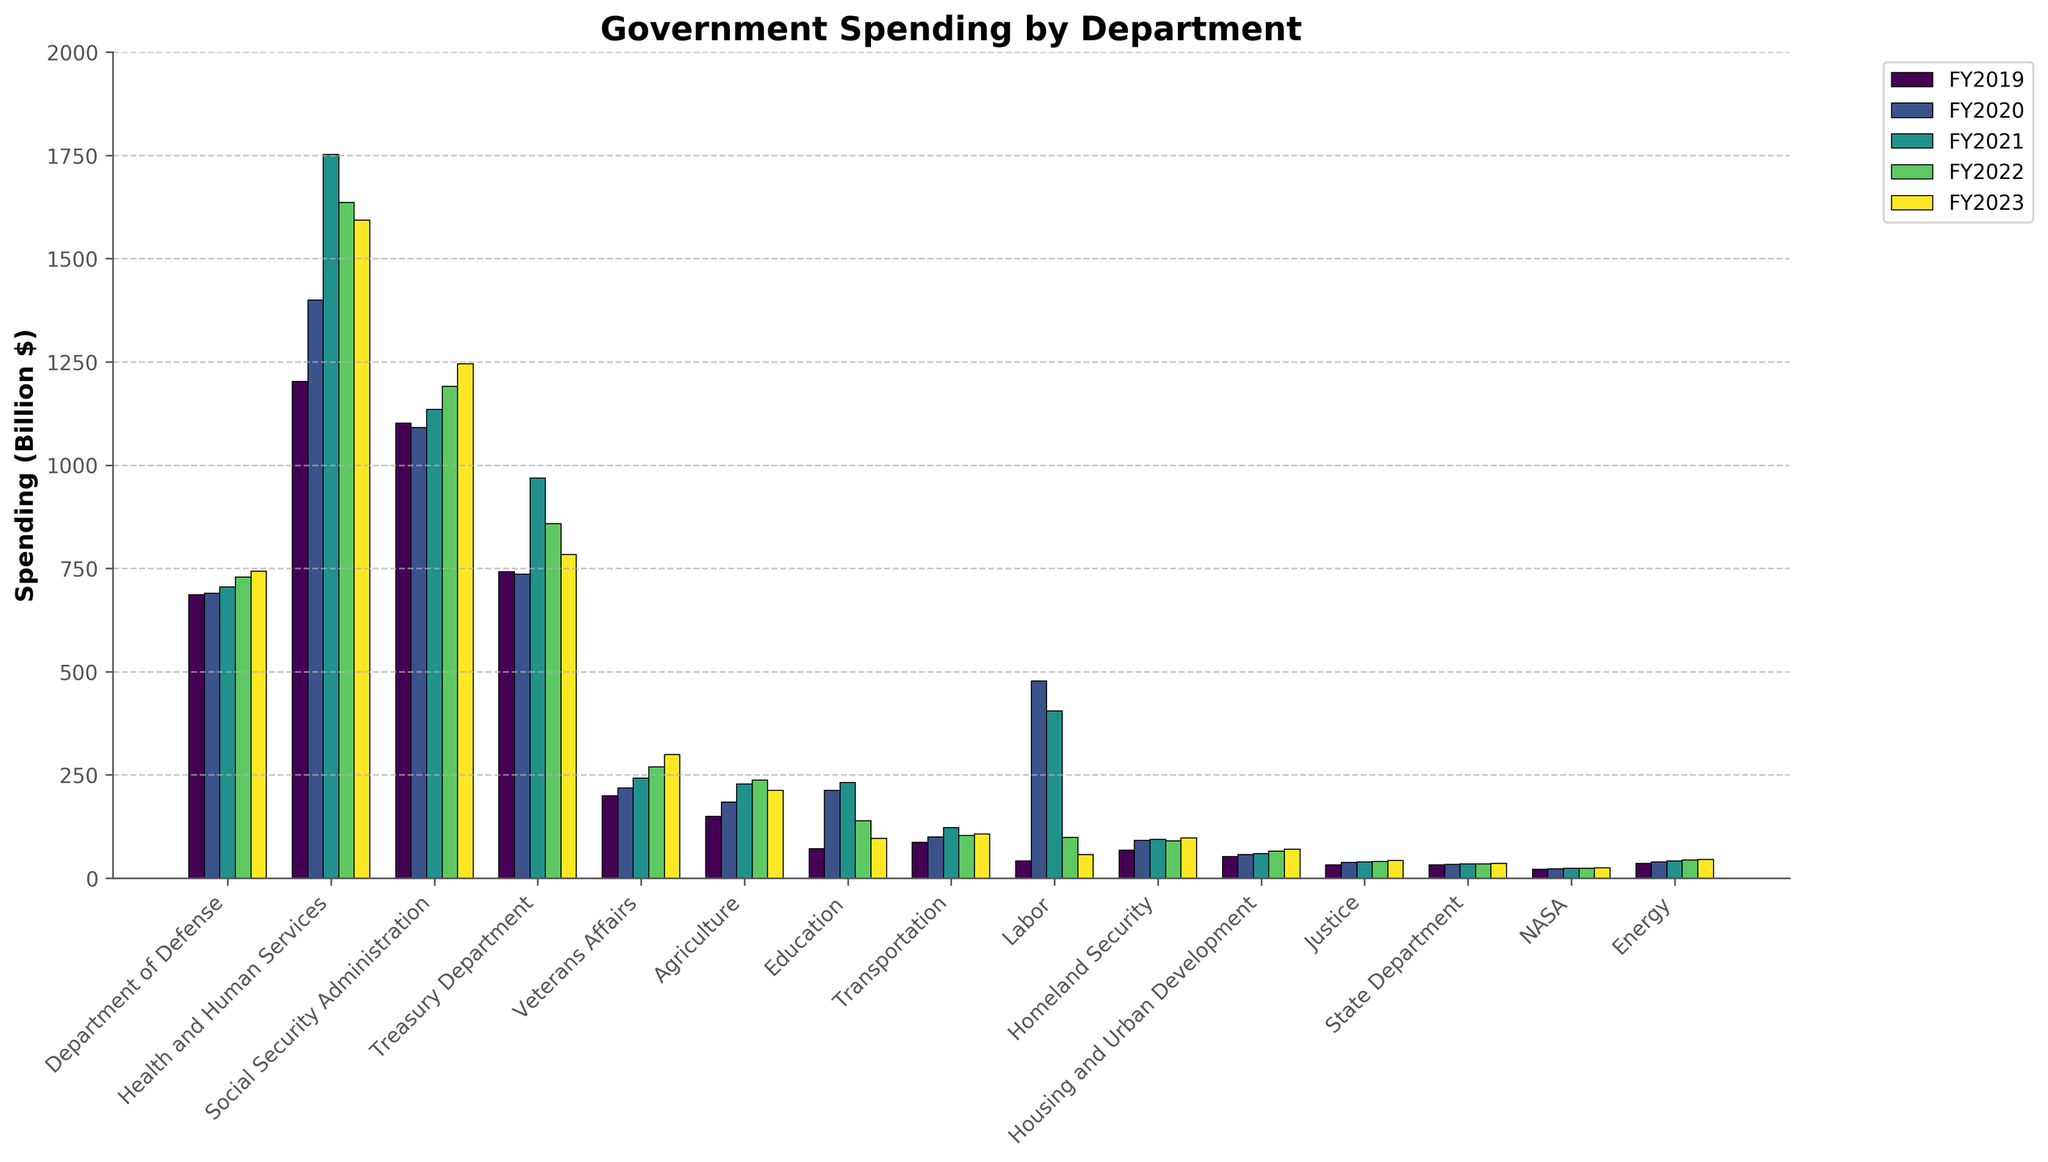What is the total amount of spending by the Department of Defense over the 5 fiscal years? Sum the values for the Department of Defense across FY2019 to FY2023: 686.1 + 690.0 + 705.4 + 728.5 + 743.2 = 3553.2
Answer: 3553.2 Which department had the highest spending in any single fiscal year displayed in the figure? Health and Human Services had the highest spending in FY2021 with an amount of 1751.9 billion dollars.
Answer: Health and Human Services How did the spending for the Agriculture department change from FY2020 to FY2023? In FY2020, Agriculture spent 184.2 billion dollars. By FY2023, spending decreased to 212.5 billion dollars. The difference is 212.5 - 184.2 = 28.3 billion dollars.
Answer: Increased by 28.3 Compare the FY2023 spending between the Department of Education and the Department of Labor. The Department of Education spent 96.4 billion dollars in FY2023, while the Department of Labor spent 57.3 billion dollars. 96.4 > 57.3.
Answer: Education spent more What is the average spending of the Treasury Department over the 5 fiscal years? Sum the values for the Treasury Department and divide by 5: (741.8 + 735.9 + 969.3 + 858.6 + 783.2) / 5 = 817.76
Answer: 817.76 Which department shows a consistent increase in spending over the five years without any decline? The Department of Veterans Affairs shows a consistent increase from 199.2 in FY2019 to 298.7 in FY2023.
Answer: Veterans Affairs How many fiscal years did the Department of Energy have a spending above 40 billion dollars? FY2021, FY2022, and FY2023 show spending values of 41.9, 44.0, and 45.3 billion dollars, respectively. That's 3 fiscal years.
Answer: 3 Which year had the most significant decrease in spending for the Social Security Administration compared to the previous year? Compare the year-over-year changes: FY2020 to FY2019 = -10.8, FY2021 to FY2020 = +43.9, FY2022 to FY2021 = +56.1, FY2023 to FY2022 = +54.7. The decrease was from FY2019 to FY2020.
Answer: FY2020 What is the total spending on NASA from FY2019 to FY2023? Sum the values: 21.5 + 22.6 + 23.3 + 24.0 + 24.9 = 116.3
Answer: 116.3 